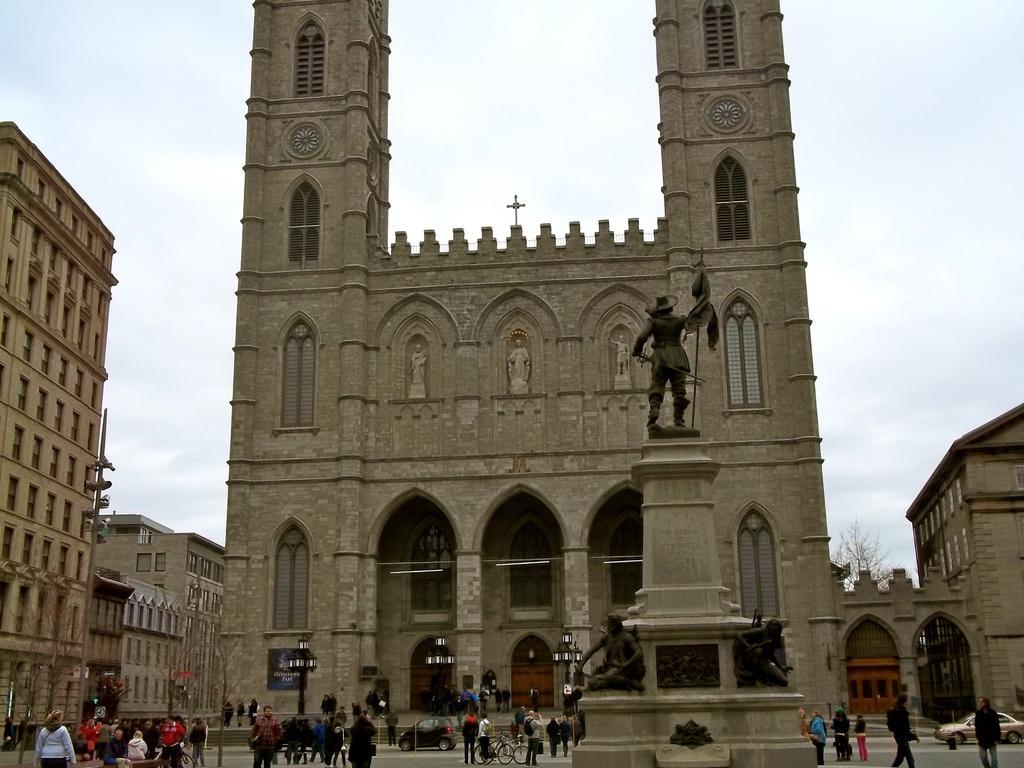How would you summarize this image in a sentence or two? In the foreground of the image we can see some persons are walking on the road. In the middle of the image we can see a building and some statues. On the top of the image we can see the sky and a plus symbol. 